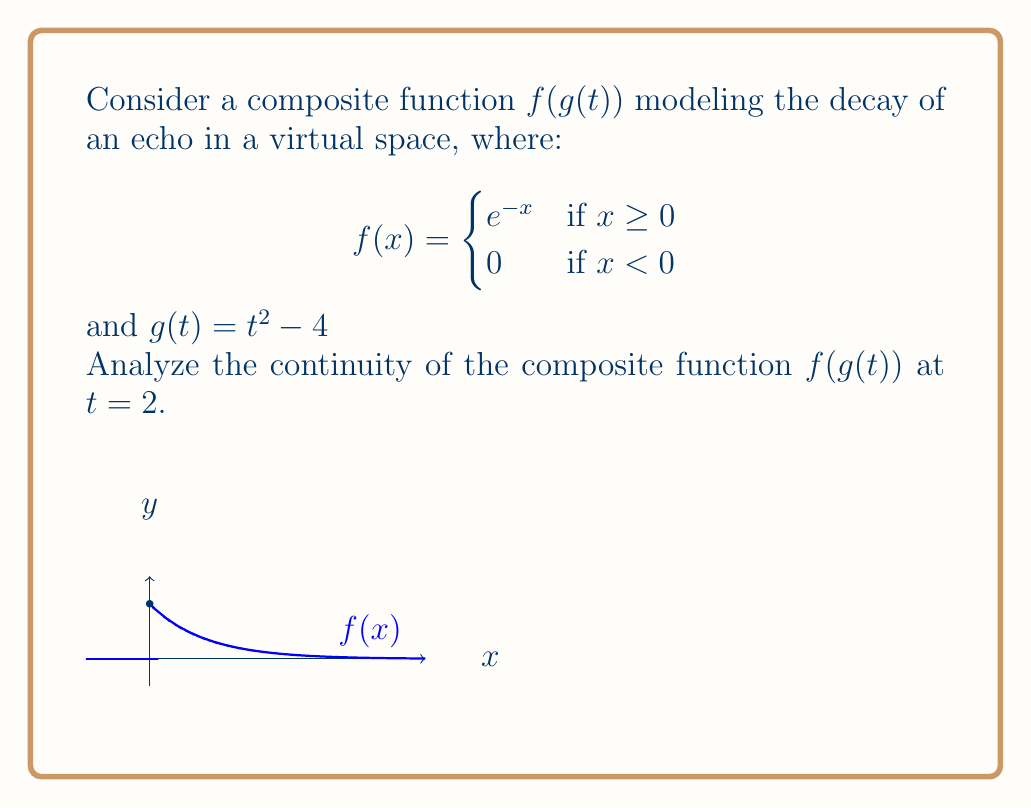Could you help me with this problem? To analyze the continuity of $f(g(t))$ at $t = 2$, we need to check if the following conditions are met:

1) $g(t)$ is continuous at $t = 2$
2) $f(x)$ is continuous at $x = g(2)$
3) The composition $f(g(t))$ is defined at and near $t = 2$

Step 1: Check continuity of $g(t)$ at $t = 2$
$g(t) = t^2 - 4$ is a polynomial function, which is continuous for all real numbers. Therefore, $g(t)$ is continuous at $t = 2$.

Step 2: Evaluate $g(2)$
$g(2) = 2^2 - 4 = 0$

Step 3: Check continuity of $f(x)$ at $x = g(2) = 0$
$f(x)$ is defined piecewise:
$$f(x) = \begin{cases}
e^{-x} & \text{if } x \geq 0 \\
0 & \text{if } x < 0
\end{cases}$$

At $x = 0$:
$\lim_{x \to 0^-} f(x) = 0$
$\lim_{x \to 0^+} f(x) = e^0 = 1$
$f(0) = e^0 = 1$ (since $0 \geq 0$)

Since the left-hand limit doesn't equal the right-hand limit, $f(x)$ is not continuous at $x = 0$.

Step 4: Evaluate $f(g(t))$ near $t = 2$
For $t < 2$: $g(t) < 0$, so $f(g(t)) = 0$
For $t \geq 2$: $g(t) \geq 0$, so $f(g(t)) = e^{-(t^2-4)}$

Step 5: Check limits of $f(g(t))$ as $t$ approaches 2
$\lim_{t \to 2^-} f(g(t)) = 0$
$\lim_{t \to 2^+} f(g(t)) = e^{-(2^2-4)} = e^0 = 1$
$f(g(2)) = f(0) = 1$

Since the left-hand limit doesn't equal the right-hand limit, $f(g(t))$ is not continuous at $t = 2$.
Answer: $f(g(t))$ is not continuous at $t = 2$ 